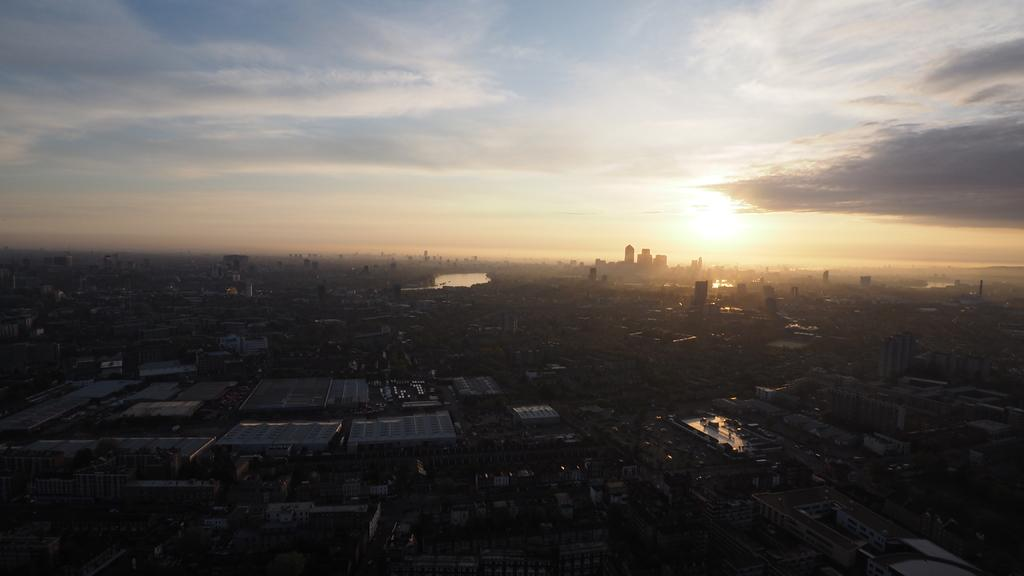What type of structures can be seen in the image? There are buildings in the image. What natural element is visible in the image? Water is visible in the image. What part of the sky can be seen in the image? The sky is visible in the image. What atmospheric feature is present in the sky? Clouds are present in the sky. Where is the scarecrow located in the image? There is no scarecrow present in the image. What type of care is being provided to the buildings in the image? The image does not show any care being provided to the buildings; it only shows their appearance. 